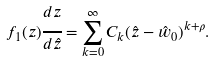Convert formula to latex. <formula><loc_0><loc_0><loc_500><loc_500>f _ { 1 } ( z ) \cfrac { d z } { d \hat { z } } = \sum _ { k = 0 } ^ { \infty } C _ { k } ( \hat { z } - \hat { w } _ { 0 } ) ^ { k + \rho } .</formula> 